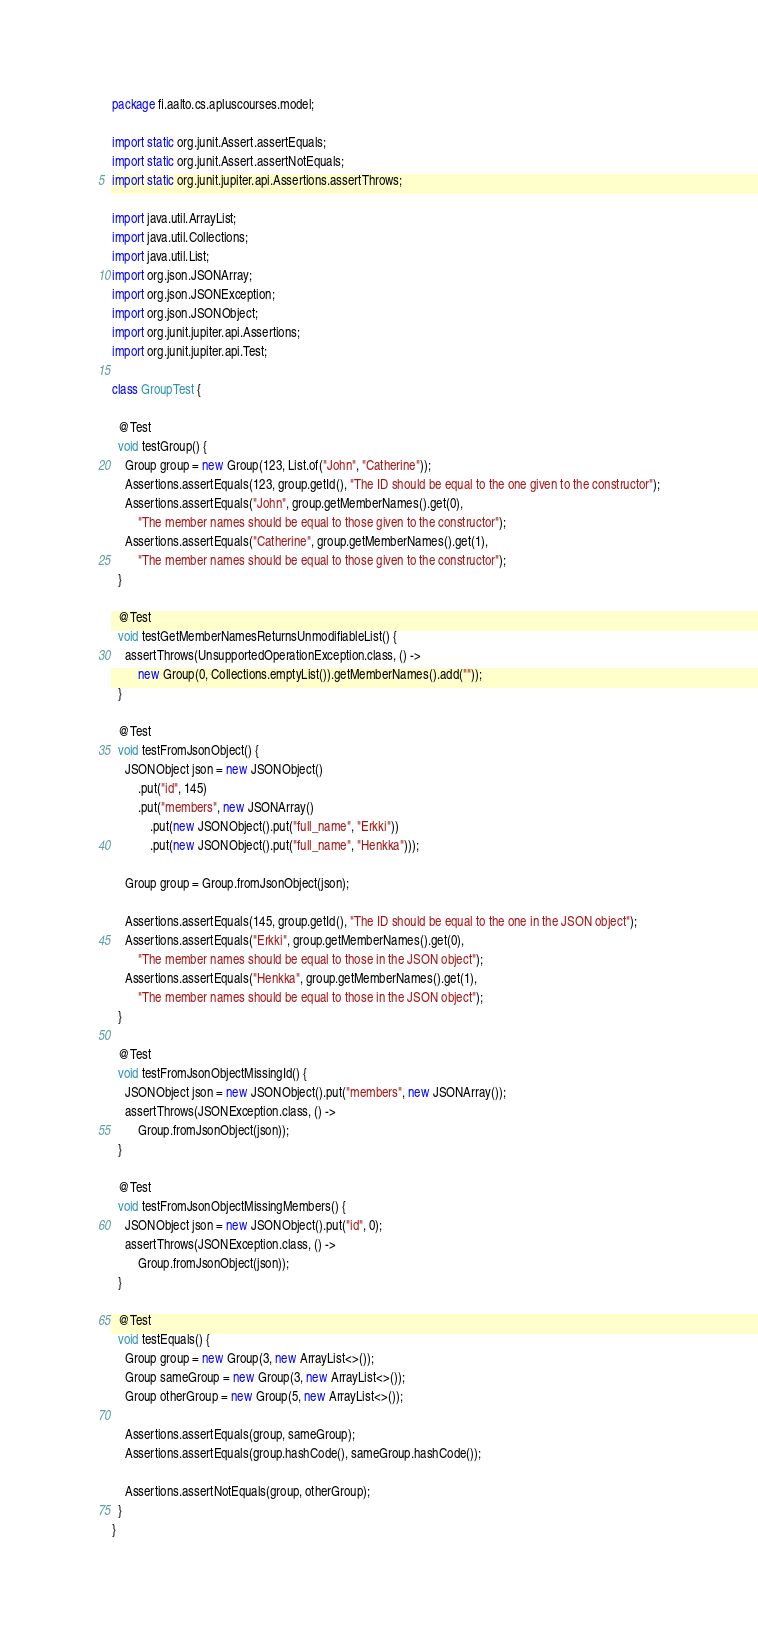<code> <loc_0><loc_0><loc_500><loc_500><_Java_>package fi.aalto.cs.apluscourses.model;

import static org.junit.Assert.assertEquals;
import static org.junit.Assert.assertNotEquals;
import static org.junit.jupiter.api.Assertions.assertThrows;

import java.util.ArrayList;
import java.util.Collections;
import java.util.List;
import org.json.JSONArray;
import org.json.JSONException;
import org.json.JSONObject;
import org.junit.jupiter.api.Assertions;
import org.junit.jupiter.api.Test;

class GroupTest {

  @Test
  void testGroup() {
    Group group = new Group(123, List.of("John", "Catherine"));
    Assertions.assertEquals(123, group.getId(), "The ID should be equal to the one given to the constructor");
    Assertions.assertEquals("John", group.getMemberNames().get(0),
        "The member names should be equal to those given to the constructor");
    Assertions.assertEquals("Catherine", group.getMemberNames().get(1),
        "The member names should be equal to those given to the constructor");
  }

  @Test
  void testGetMemberNamesReturnsUnmodifiableList() {
    assertThrows(UnsupportedOperationException.class, () ->
        new Group(0, Collections.emptyList()).getMemberNames().add(""));
  }

  @Test
  void testFromJsonObject() {
    JSONObject json = new JSONObject()
        .put("id", 145)
        .put("members", new JSONArray()
            .put(new JSONObject().put("full_name", "Erkki"))
            .put(new JSONObject().put("full_name", "Henkka")));

    Group group = Group.fromJsonObject(json);

    Assertions.assertEquals(145, group.getId(), "The ID should be equal to the one in the JSON object");
    Assertions.assertEquals("Erkki", group.getMemberNames().get(0),
        "The member names should be equal to those in the JSON object");
    Assertions.assertEquals("Henkka", group.getMemberNames().get(1),
        "The member names should be equal to those in the JSON object");
  }

  @Test
  void testFromJsonObjectMissingId() {
    JSONObject json = new JSONObject().put("members", new JSONArray());
    assertThrows(JSONException.class, () ->
        Group.fromJsonObject(json));
  }

  @Test
  void testFromJsonObjectMissingMembers() {
    JSONObject json = new JSONObject().put("id", 0);
    assertThrows(JSONException.class, () ->
        Group.fromJsonObject(json));
  }

  @Test
  void testEquals() {
    Group group = new Group(3, new ArrayList<>());
    Group sameGroup = new Group(3, new ArrayList<>());
    Group otherGroup = new Group(5, new ArrayList<>());

    Assertions.assertEquals(group, sameGroup);
    Assertions.assertEquals(group.hashCode(), sameGroup.hashCode());

    Assertions.assertNotEquals(group, otherGroup);
  }
}
</code> 